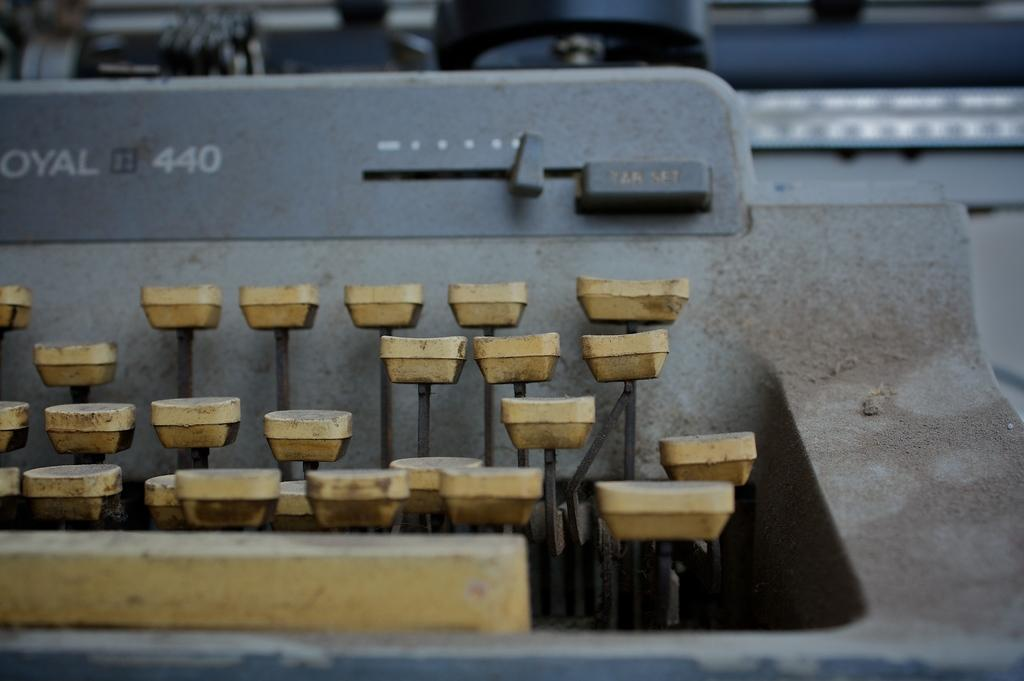<image>
Provide a brief description of the given image. an old Royal 440 type writer that is dirty 